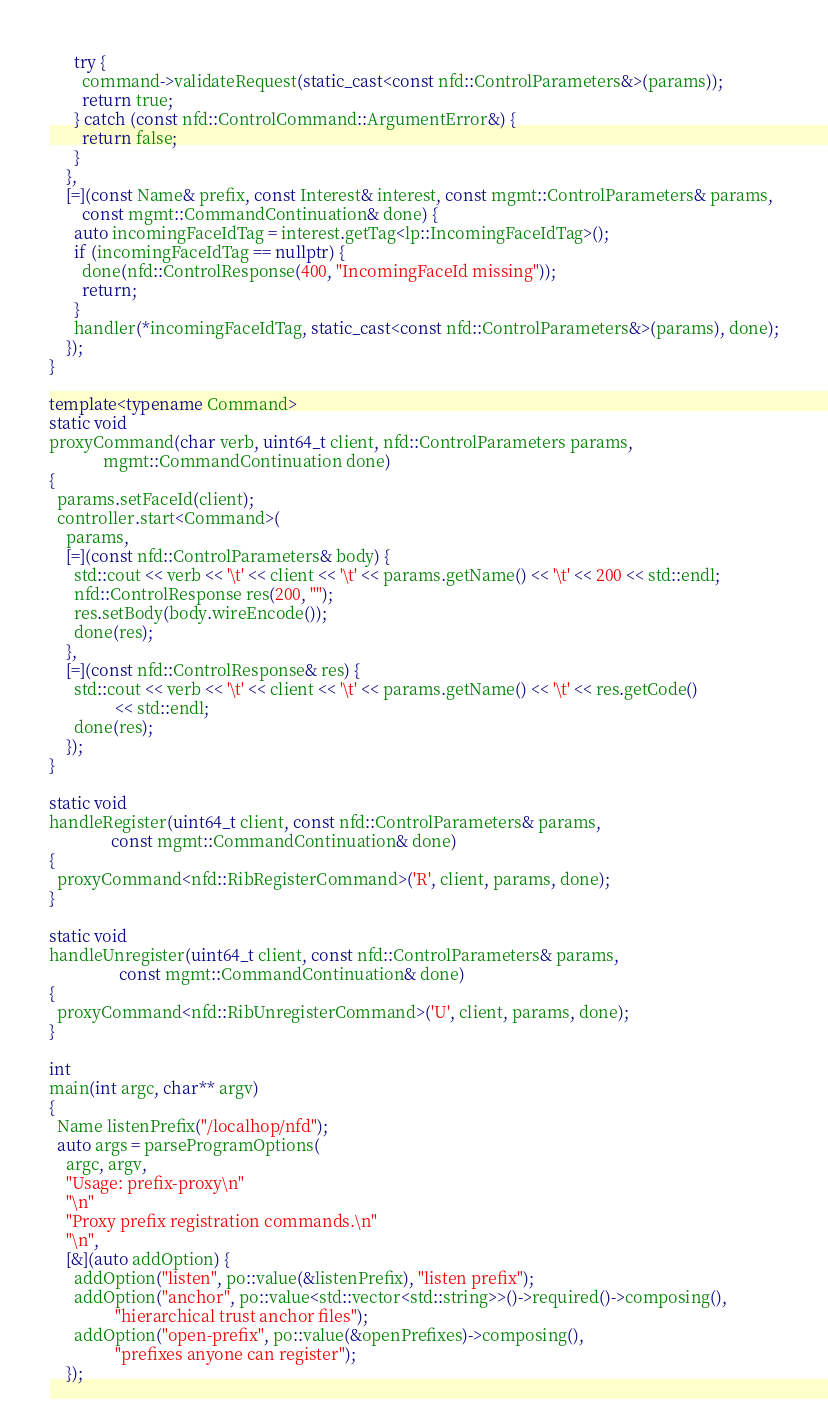Convert code to text. <code><loc_0><loc_0><loc_500><loc_500><_C++_>      try {
        command->validateRequest(static_cast<const nfd::ControlParameters&>(params));
        return true;
      } catch (const nfd::ControlCommand::ArgumentError&) {
        return false;
      }
    },
    [=](const Name& prefix, const Interest& interest, const mgmt::ControlParameters& params,
        const mgmt::CommandContinuation& done) {
      auto incomingFaceIdTag = interest.getTag<lp::IncomingFaceIdTag>();
      if (incomingFaceIdTag == nullptr) {
        done(nfd::ControlResponse(400, "IncomingFaceId missing"));
        return;
      }
      handler(*incomingFaceIdTag, static_cast<const nfd::ControlParameters&>(params), done);
    });
}

template<typename Command>
static void
proxyCommand(char verb, uint64_t client, nfd::ControlParameters params,
             mgmt::CommandContinuation done)
{
  params.setFaceId(client);
  controller.start<Command>(
    params,
    [=](const nfd::ControlParameters& body) {
      std::cout << verb << '\t' << client << '\t' << params.getName() << '\t' << 200 << std::endl;
      nfd::ControlResponse res(200, "");
      res.setBody(body.wireEncode());
      done(res);
    },
    [=](const nfd::ControlResponse& res) {
      std::cout << verb << '\t' << client << '\t' << params.getName() << '\t' << res.getCode()
                << std::endl;
      done(res);
    });
}

static void
handleRegister(uint64_t client, const nfd::ControlParameters& params,
               const mgmt::CommandContinuation& done)
{
  proxyCommand<nfd::RibRegisterCommand>('R', client, params, done);
}

static void
handleUnregister(uint64_t client, const nfd::ControlParameters& params,
                 const mgmt::CommandContinuation& done)
{
  proxyCommand<nfd::RibUnregisterCommand>('U', client, params, done);
}

int
main(int argc, char** argv)
{
  Name listenPrefix("/localhop/nfd");
  auto args = parseProgramOptions(
    argc, argv,
    "Usage: prefix-proxy\n"
    "\n"
    "Proxy prefix registration commands.\n"
    "\n",
    [&](auto addOption) {
      addOption("listen", po::value(&listenPrefix), "listen prefix");
      addOption("anchor", po::value<std::vector<std::string>>()->required()->composing(),
                "hierarchical trust anchor files");
      addOption("open-prefix", po::value(&openPrefixes)->composing(),
                "prefixes anyone can register");
    });
</code> 